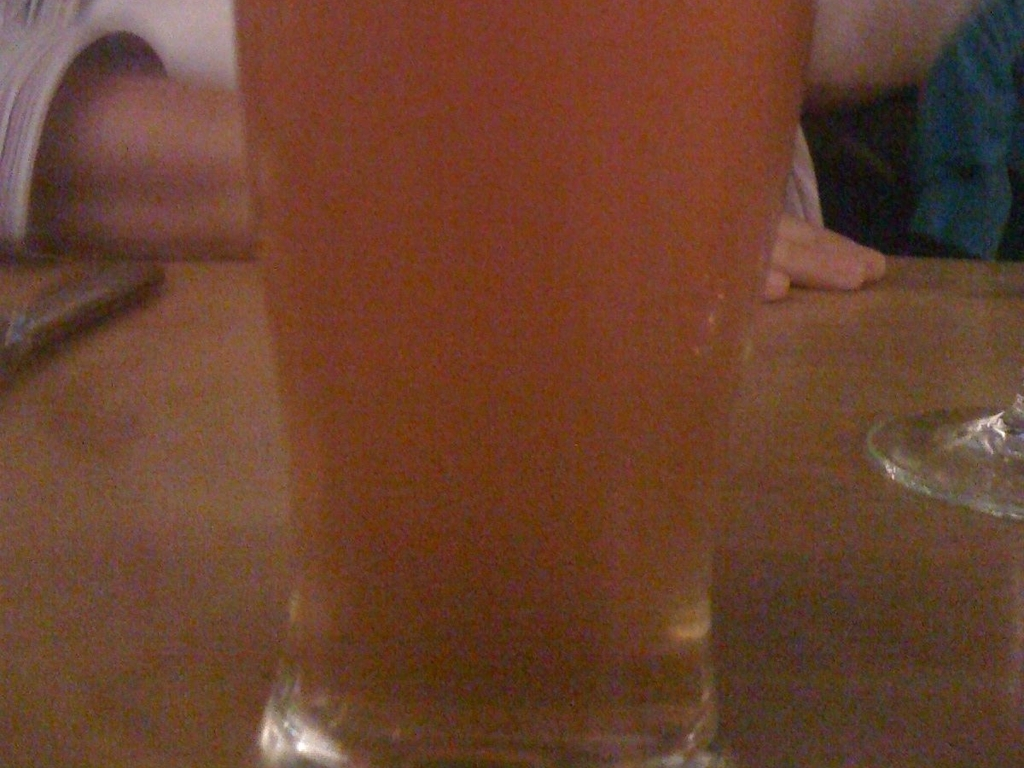Are the arms of the person in the background clear? The image provided is too blurry to discern any clear details, making it impossible to comment on the clarity of the person's arms in the background. 